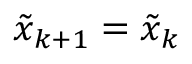Convert formula to latex. <formula><loc_0><loc_0><loc_500><loc_500>\tilde { x } _ { k + 1 } = \tilde { x } _ { k }</formula> 